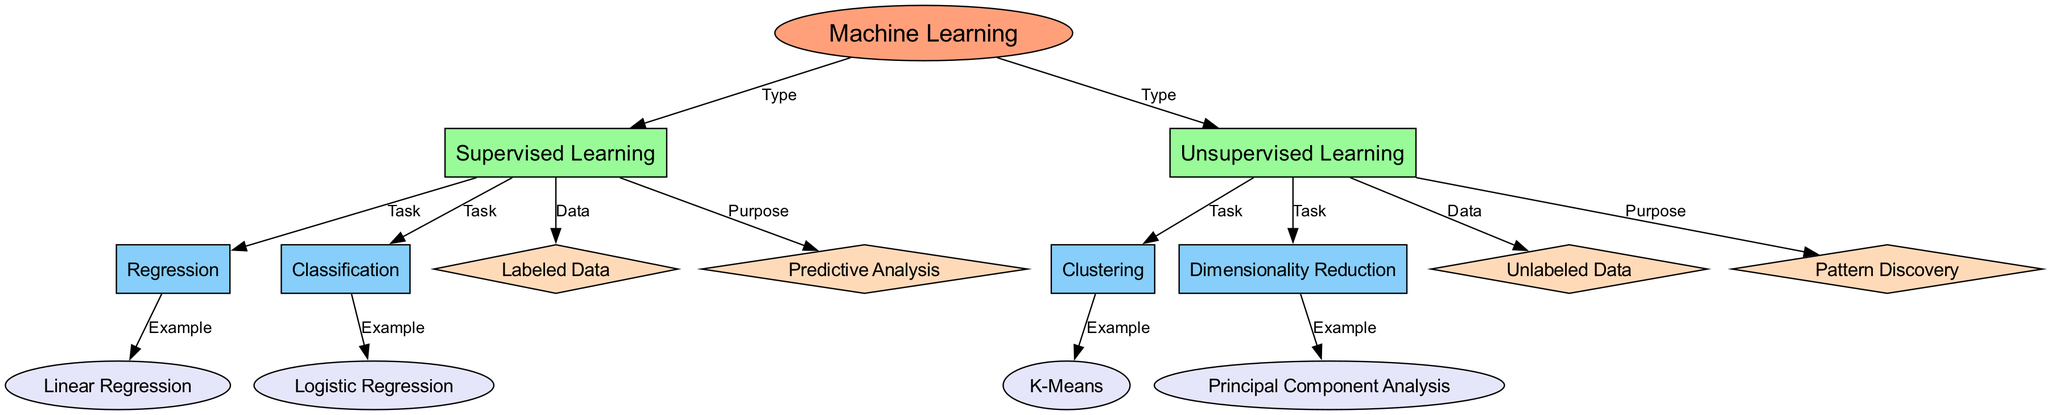What are the two main types of machine learning shown in the diagram? The diagram lists "Supervised Learning" and "Unsupervised Learning" as the two types directly connected to "Machine Learning."
Answer: Supervised Learning, Unsupervised Learning How many tasks are associated with supervised learning? The diagram shows two tasks under "Supervised Learning": "Regression" and "Classification," establishing a clear connection.
Answer: 2 Which type of data is used in supervised learning? The diagram indicates that "Labeled Data" is associated with "Supervised Learning," meaning data that has known outcomes or labels.
Answer: Labeled Data What is an example of clustering in unsupervised learning? The diagram indicates "K-Means" connected to "Clustering," which is an algorithm used for grouping data points without prior labeling.
Answer: K-Means What purpose does supervised learning fulfill? According to the diagram, "Predictive Analysis" is linked to "Supervised Learning," suggesting its main purpose is to predict outcomes based on data.
Answer: Predictive Analysis How do unsupervised learning tasks differ from supervised learning tasks? The diagram indicates that while supervised learning tasks focus on predicting labels (Regression and Classification), unsupervised learning tasks focus on analyzing unlabeled data (Clustering and Dimensionality Reduction).
Answer: They analyze unlabeled data Which algorithm is associated with dimensionality reduction? The diagram identifies "Principal Component Analysis" as the algorithm linked to "Dimensionality Reduction" under the unsupervised learning section.
Answer: Principal Component Analysis What is the main difference in data used between supervised and unsupervised learning? The diagram clearly separates "Labeled Data" for supervised learning from "Unlabeled Data" for unsupervised learning, emphasizing this key distinction.
Answer: Labeled Data vs. Unlabeled Data What is the relationship between regression and linear regression in the diagram? "Linear Regression" is shown as an example stemming from "Regression," illustrating that it is a specific type of regression task under supervised learning.
Answer: Linear Regression is an example of Regression 